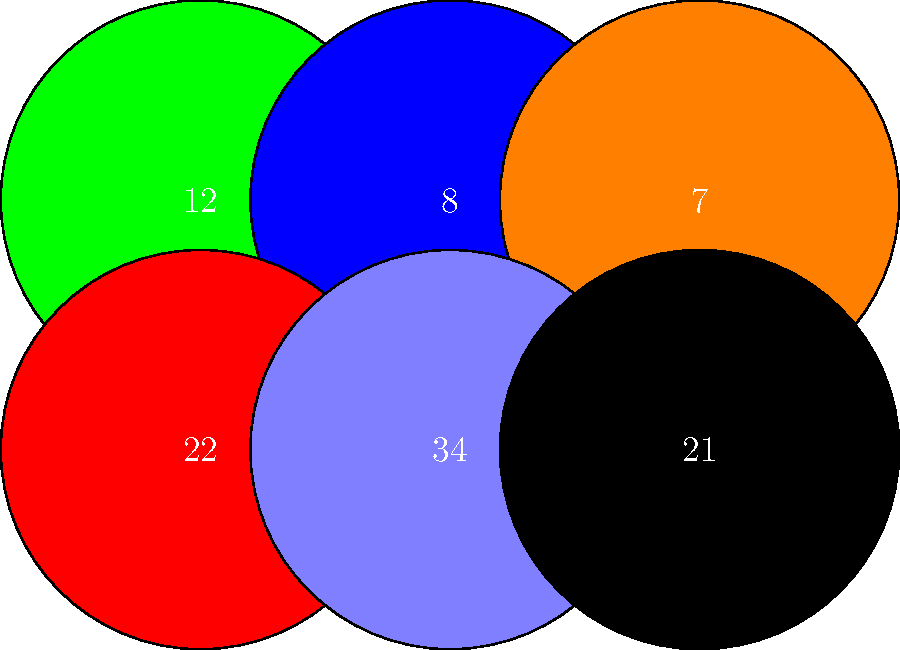Which 90s NFL legend wore the jersey number 34 and played for a team with blue and white as their primary colors? To answer this question, we need to analyze the simplified jersey designs provided in the image and recall our knowledge of 90s NFL players. Let's break it down step-by-step:

1. The image shows six simplified jerseys with different numbers and colors.
2. We're specifically looking for jersey number 34 with blue and white colors.
3. In the bottom row, second from the left, we see a jersey with the number 34 in blue and white.
4. Now, we need to think about famous 90s NFL players who wore number 34 for a team with blue and white colors.
5. The most iconic player fitting this description is Bo Jackson, who played for the Los Angeles Raiders (now Las Vegas Raiders) from 1987 to 1990.
6. Although the Raiders are known for their silver and black, their away jerseys featured white with blue numbers, which matches the simplified design in the image.
7. Bo Jackson was a two-sport athlete (NFL and MLB) and one of the most dynamic running backs of his era, making him a legend of 90s football despite his short career due to injury.

Therefore, based on the jersey number, team colors, and the player's legendary status in 90s NFL, the answer is Bo Jackson.
Answer: Bo Jackson 